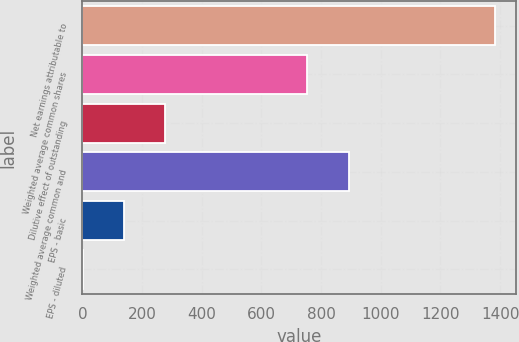<chart> <loc_0><loc_0><loc_500><loc_500><bar_chart><fcel>Net earnings attributable to<fcel>Weighted average common shares<fcel>Dilutive effect of outstanding<fcel>Weighted average common and<fcel>EPS - basic<fcel>EPS - diluted<nl><fcel>1383.8<fcel>754.4<fcel>278.19<fcel>892.6<fcel>139.99<fcel>1.79<nl></chart> 